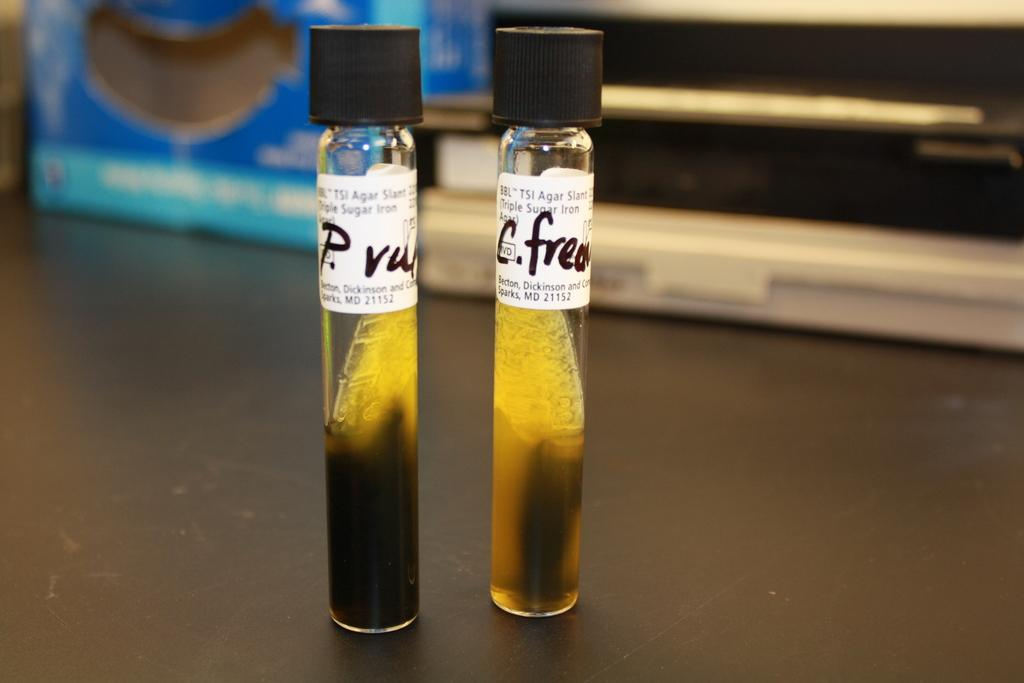<image>
Relay a brief, clear account of the picture shown. Two test tube sit on a black counter one reads c. frea 